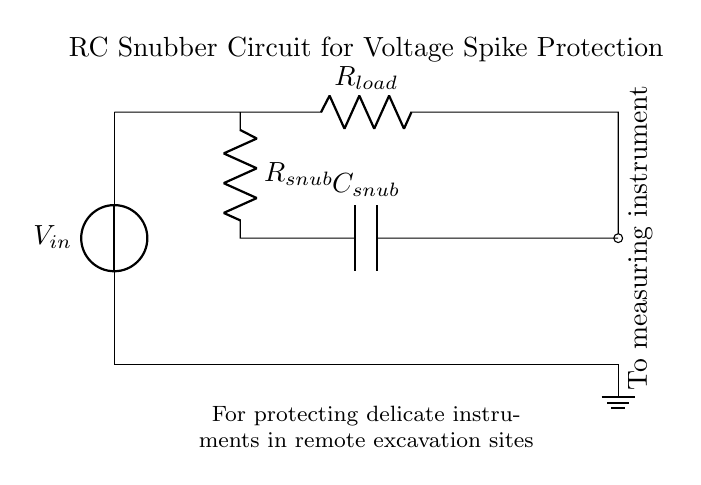What does the symbol V in the circuit represent? The symbol V in the circuit represents the voltage source. It is typically the starting point for providing electrical energy to the circuit.
Answer: Voltage source What is the role of the resistor labeled R_load? The resistor labeled R_load serves as the load in the circuit that the measuring instrument interacts with. It helps to limit the current flowing to prevent damage to sensitive components.
Answer: Load resistor How many capacitors are present in the circuit? The circuit contains one capacitor, which is part of the snubber circuit designed to mitigate voltage spikes.
Answer: One What is the function of the snubber circuit? The snubber circuit is designed to protect delicate measuring instruments from voltage spikes by absorbing excess energy and smoothing out transient voltages, which helps to prevent damage to the instruments.
Answer: Protect delicate instruments If R_snub is 10 ohms and C_snub is 100 microfarads, what can be inferred about the RC time constant of the snubber circuit? The RC time constant can be calculated using the formula τ = R * C. In this case, τ = 10 ohms * 100 microfarads = 1 millisecond, indicating how quickly the snubber can respond to changes in voltage.
Answer: 1 millisecond What is the connection type between the capacitor and the resistor in the snubber circuit? The capacitor and the resistor in the snubber circuit are connected in series. This is a common arrangement for RC circuits that work together to filter voltage spikes.
Answer: Series connection 